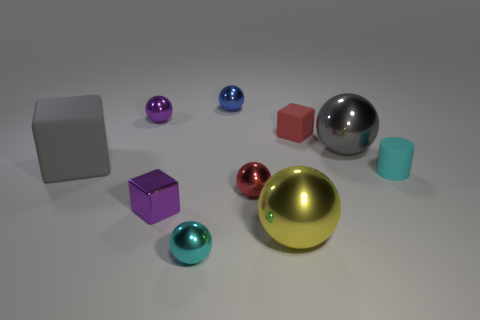Subtract all big gray matte blocks. How many blocks are left? 2 Subtract all spheres. How many objects are left? 4 Subtract all gray blocks. How many blocks are left? 2 Add 5 yellow shiny things. How many yellow shiny things are left? 6 Add 8 large gray metallic spheres. How many large gray metallic spheres exist? 9 Subtract 0 brown balls. How many objects are left? 10 Subtract 3 cubes. How many cubes are left? 0 Subtract all blue cylinders. Subtract all yellow balls. How many cylinders are left? 1 Subtract all green cubes. How many green spheres are left? 0 Subtract all tiny blue shiny spheres. Subtract all small red blocks. How many objects are left? 8 